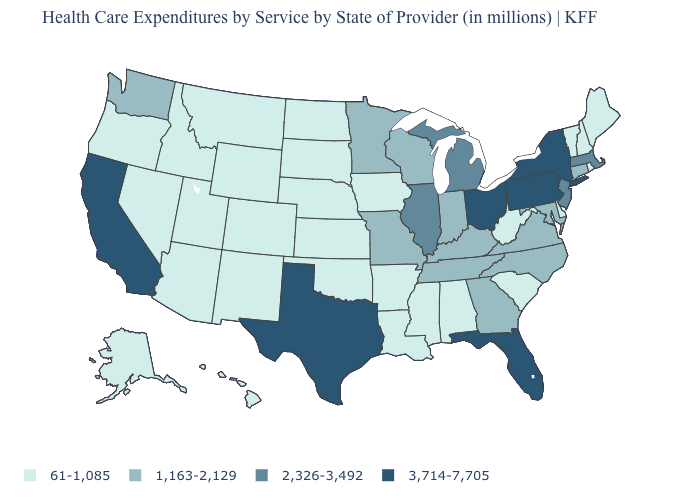Which states have the highest value in the USA?
Concise answer only. California, Florida, New York, Ohio, Pennsylvania, Texas. Among the states that border Oklahoma , which have the highest value?
Short answer required. Texas. Does the first symbol in the legend represent the smallest category?
Quick response, please. Yes. What is the value of West Virginia?
Short answer required. 61-1,085. What is the value of California?
Short answer required. 3,714-7,705. Name the states that have a value in the range 2,326-3,492?
Be succinct. Illinois, Massachusetts, Michigan, New Jersey. Name the states that have a value in the range 2,326-3,492?
Quick response, please. Illinois, Massachusetts, Michigan, New Jersey. How many symbols are there in the legend?
Keep it brief. 4. Does Nebraska have the lowest value in the USA?
Quick response, please. Yes. Does the first symbol in the legend represent the smallest category?
Keep it brief. Yes. Which states have the lowest value in the USA?
Write a very short answer. Alabama, Alaska, Arizona, Arkansas, Colorado, Delaware, Hawaii, Idaho, Iowa, Kansas, Louisiana, Maine, Mississippi, Montana, Nebraska, Nevada, New Hampshire, New Mexico, North Dakota, Oklahoma, Oregon, Rhode Island, South Carolina, South Dakota, Utah, Vermont, West Virginia, Wyoming. What is the value of New Hampshire?
Concise answer only. 61-1,085. Does the first symbol in the legend represent the smallest category?
Give a very brief answer. Yes. What is the value of Massachusetts?
Give a very brief answer. 2,326-3,492. 